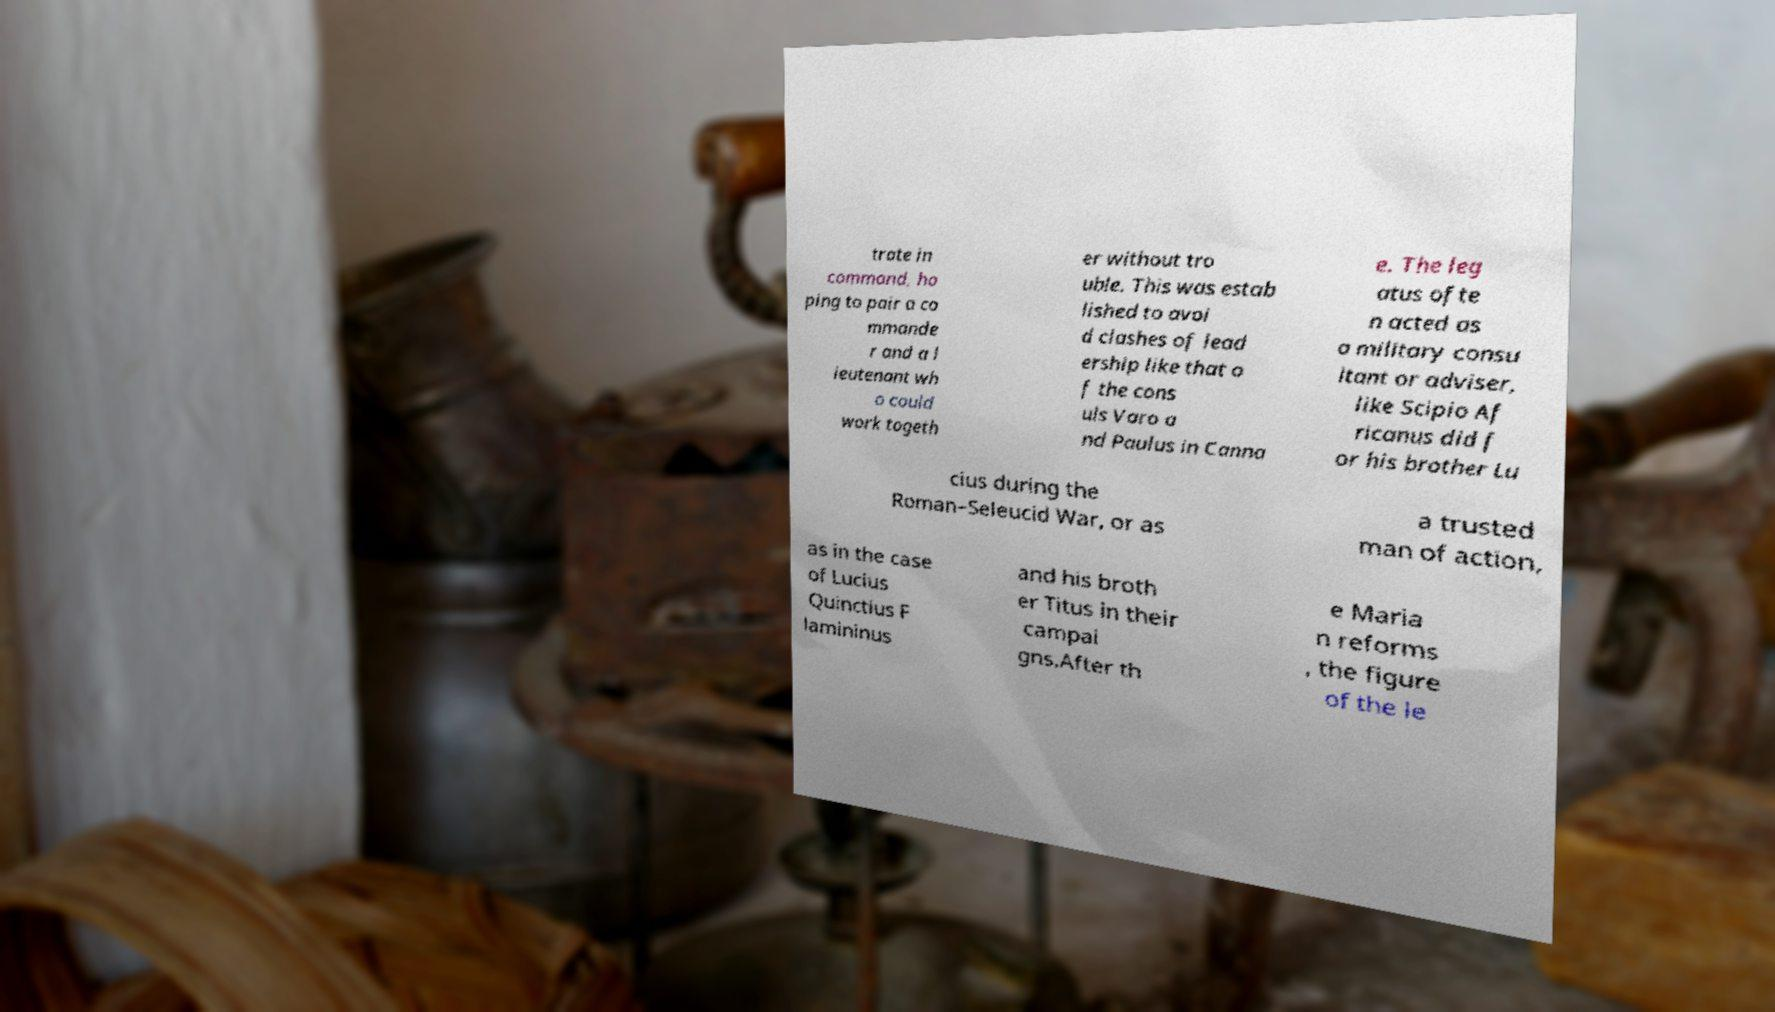What messages or text are displayed in this image? I need them in a readable, typed format. trate in command, ho ping to pair a co mmande r and a l ieutenant wh o could work togeth er without tro uble. This was estab lished to avoi d clashes of lead ership like that o f the cons uls Varo a nd Paulus in Canna e. The leg atus ofte n acted as a military consu ltant or adviser, like Scipio Af ricanus did f or his brother Lu cius during the Roman–Seleucid War, or as a trusted man of action, as in the case of Lucius Quinctius F lamininus and his broth er Titus in their campai gns.After th e Maria n reforms , the figure of the le 